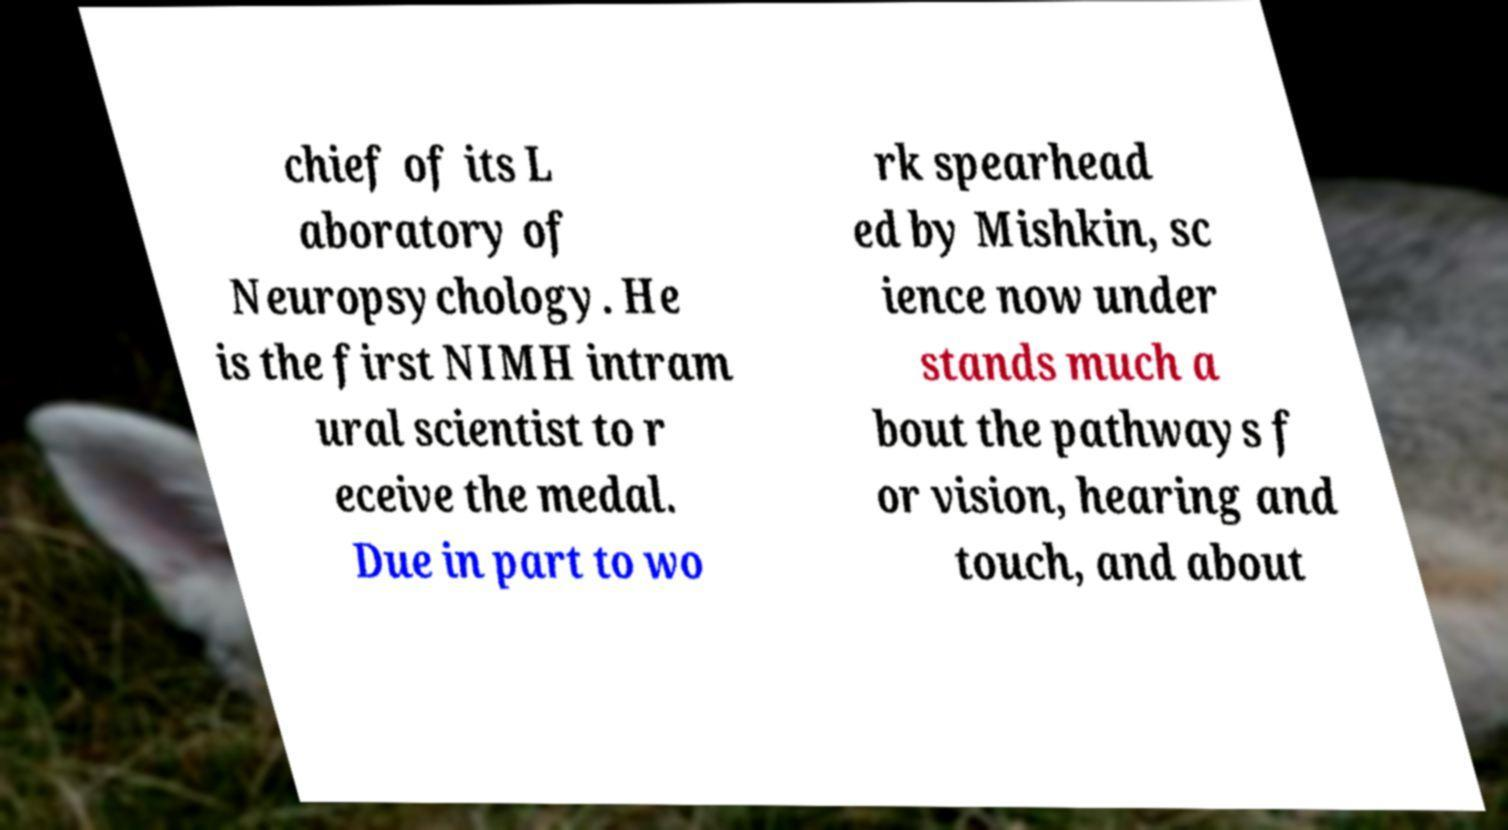Can you accurately transcribe the text from the provided image for me? chief of its L aboratory of Neuropsychology. He is the first NIMH intram ural scientist to r eceive the medal. Due in part to wo rk spearhead ed by Mishkin, sc ience now under stands much a bout the pathways f or vision, hearing and touch, and about 